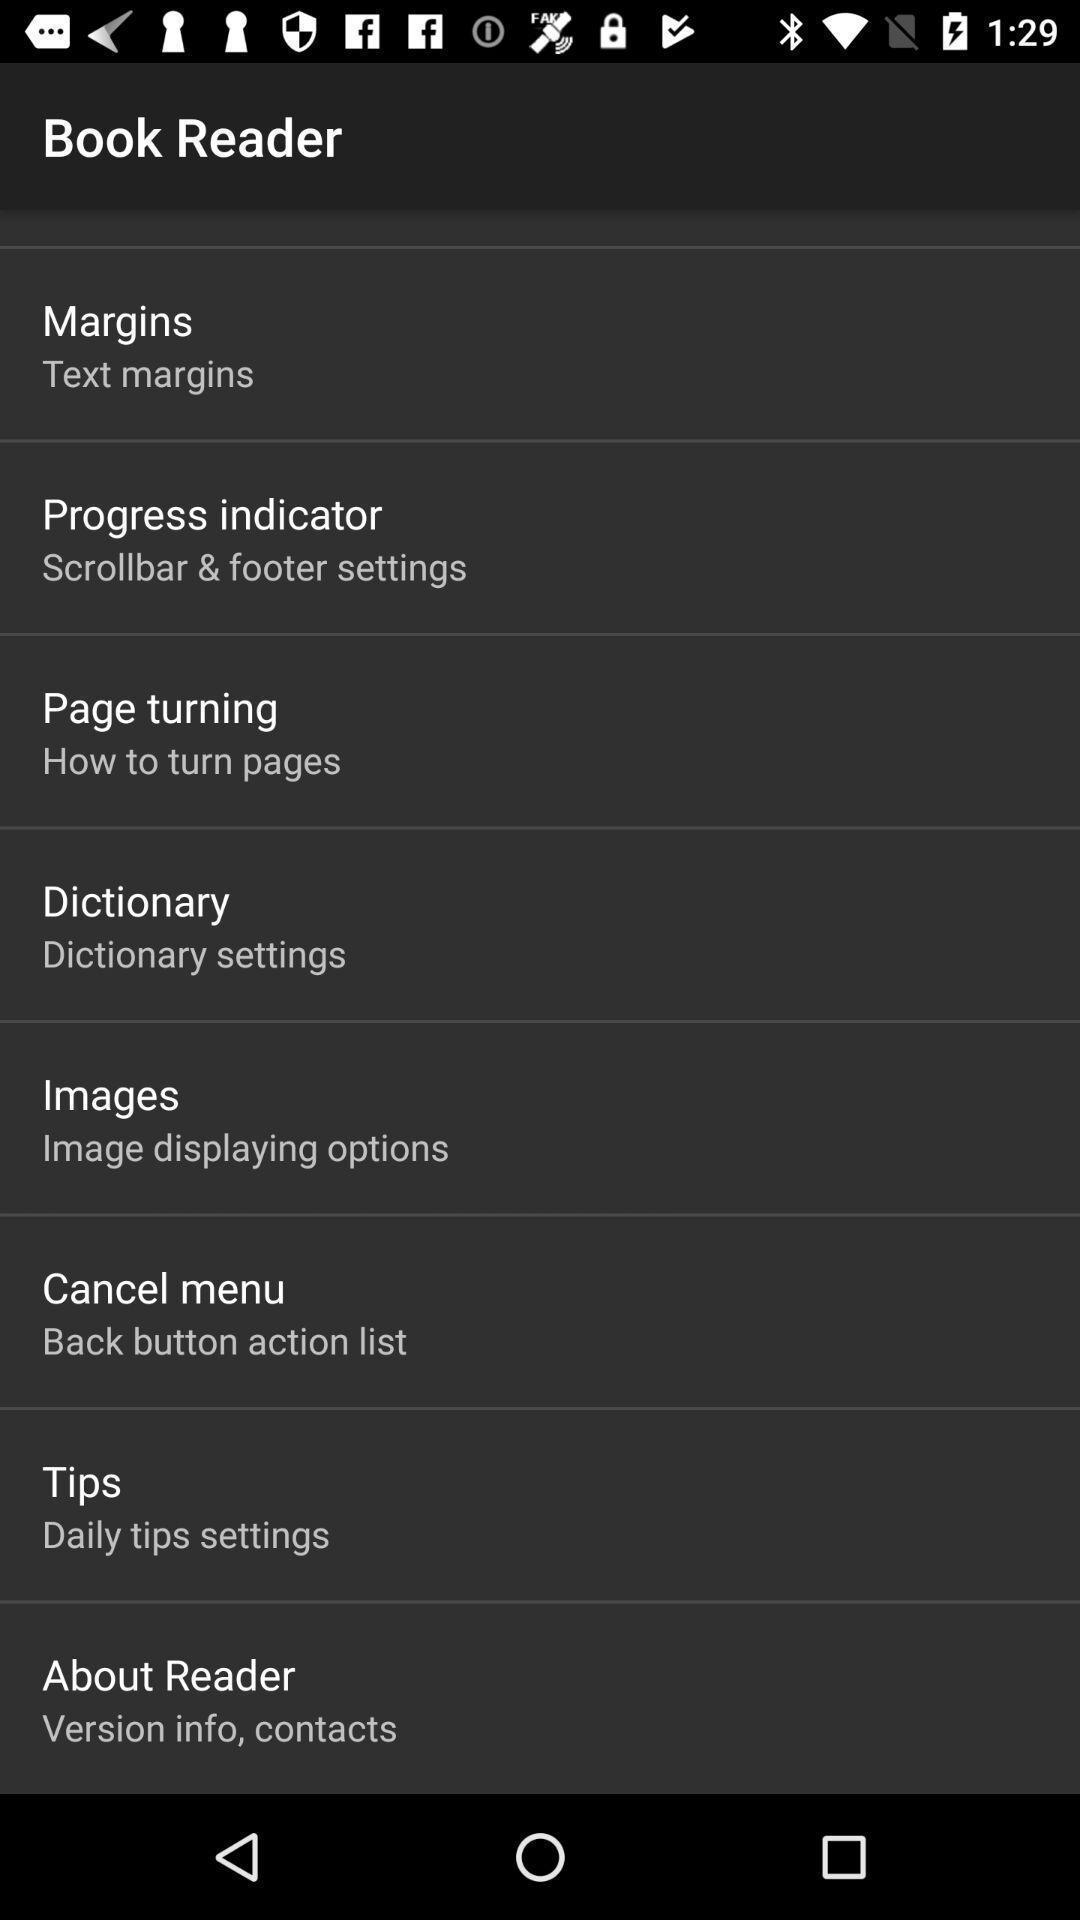Please provide a description for this image. Screen shows information about book reader. 